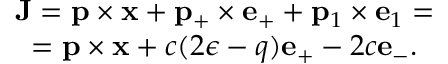<formula> <loc_0><loc_0><loc_500><loc_500>\begin{array} { c } { { { J } = { p } \times { x } + { p } _ { + } \times { e } _ { + } + { p } _ { 1 } \times { e } _ { 1 } = } } \\ { { = { p } \times { x } + c ( 2 \epsilon - q ) { e } _ { + } - 2 c { e } _ { - } . } } \end{array}</formula> 